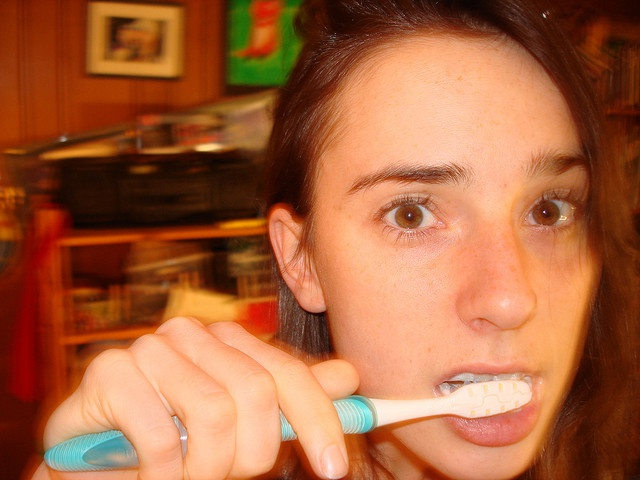Describe the objects in this image and their specific colors. I can see people in maroon, salmon, and tan tones, toothbrush in maroon, ivory, and tan tones, book in maroon and brown tones, and book in maroon tones in this image. 